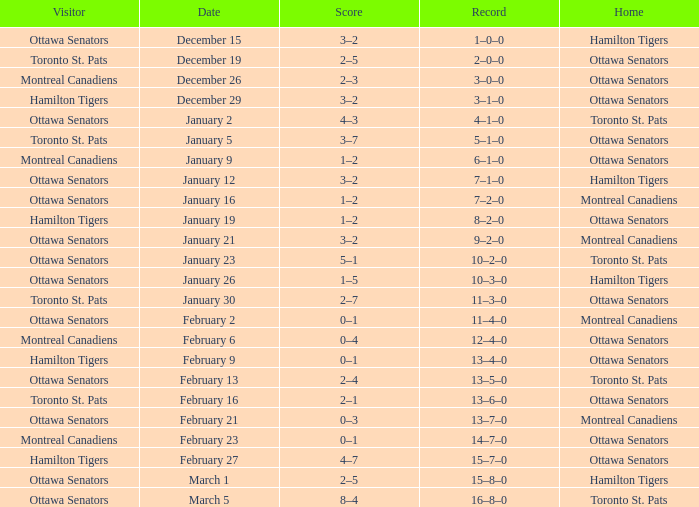Which home team had a visitor of Ottawa Senators with a score of 1–5? Hamilton Tigers. 